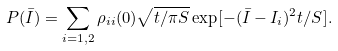Convert formula to latex. <formula><loc_0><loc_0><loc_500><loc_500>P ( \bar { I } ) = \sum _ { i = 1 , 2 } \rho _ { i i } ( 0 ) \sqrt { t / \pi S } \exp [ - ( \bar { I } - I _ { i } ) ^ { 2 } t / S ] .</formula> 